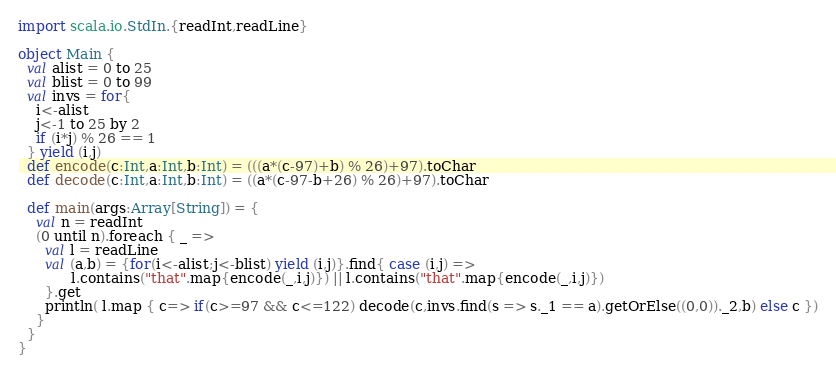Convert code to text. <code><loc_0><loc_0><loc_500><loc_500><_Scala_>import scala.io.StdIn.{readInt,readLine}

object Main {
  val alist = 0 to 25
  val blist = 0 to 99
  val invs = for{
    i<-alist
    j<-1 to 25 by 2
    if (i*j) % 26 == 1
  } yield (i,j)
  def encode(c:Int,a:Int,b:Int) = (((a*(c-97)+b) % 26)+97).toChar
  def decode(c:Int,a:Int,b:Int) = ((a*(c-97-b+26) % 26)+97).toChar

  def main(args:Array[String]) = {
    val n = readInt
    (0 until n).foreach { _ =>
      val l = readLine
      val (a,b) = {for(i<-alist;j<-blist) yield (i,j)}.find{ case (i,j) =>
            l.contains("that".map{encode(_,i,j)}) || l.contains("that".map{encode(_,i,j)})
      }.get
      println( l.map { c=> if(c>=97 && c<=122) decode(c,invs.find(s => s._1 == a).getOrElse((0,0))._2,b) else c })
    }
  }
}</code> 